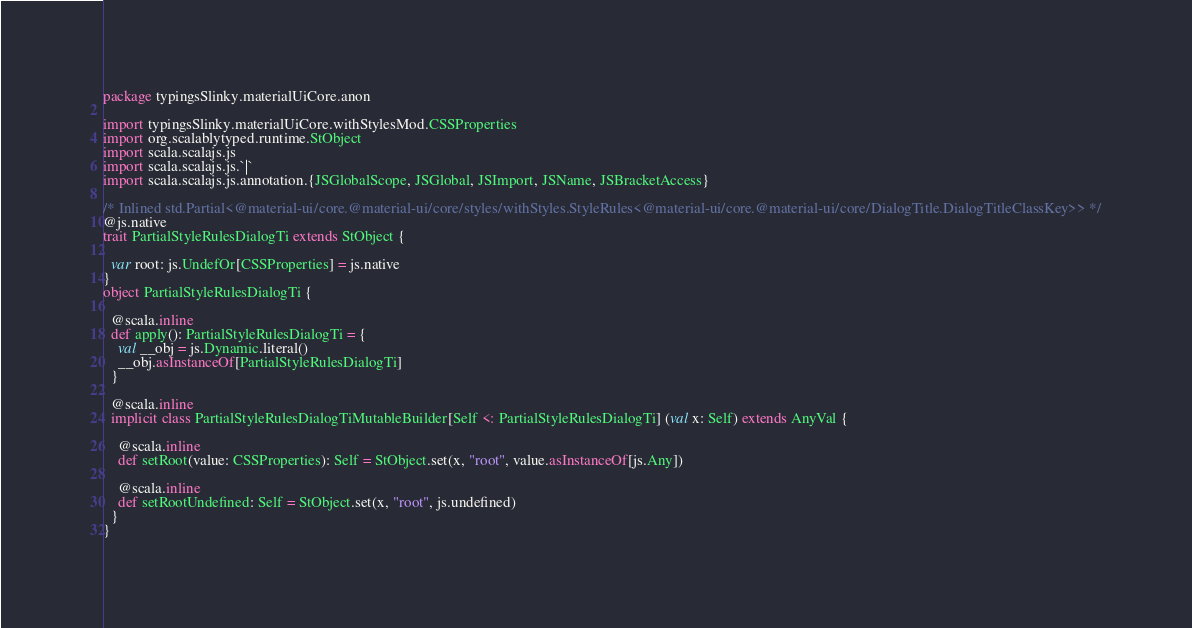Convert code to text. <code><loc_0><loc_0><loc_500><loc_500><_Scala_>package typingsSlinky.materialUiCore.anon

import typingsSlinky.materialUiCore.withStylesMod.CSSProperties
import org.scalablytyped.runtime.StObject
import scala.scalajs.js
import scala.scalajs.js.`|`
import scala.scalajs.js.annotation.{JSGlobalScope, JSGlobal, JSImport, JSName, JSBracketAccess}

/* Inlined std.Partial<@material-ui/core.@material-ui/core/styles/withStyles.StyleRules<@material-ui/core.@material-ui/core/DialogTitle.DialogTitleClassKey>> */
@js.native
trait PartialStyleRulesDialogTi extends StObject {
  
  var root: js.UndefOr[CSSProperties] = js.native
}
object PartialStyleRulesDialogTi {
  
  @scala.inline
  def apply(): PartialStyleRulesDialogTi = {
    val __obj = js.Dynamic.literal()
    __obj.asInstanceOf[PartialStyleRulesDialogTi]
  }
  
  @scala.inline
  implicit class PartialStyleRulesDialogTiMutableBuilder[Self <: PartialStyleRulesDialogTi] (val x: Self) extends AnyVal {
    
    @scala.inline
    def setRoot(value: CSSProperties): Self = StObject.set(x, "root", value.asInstanceOf[js.Any])
    
    @scala.inline
    def setRootUndefined: Self = StObject.set(x, "root", js.undefined)
  }
}
</code> 